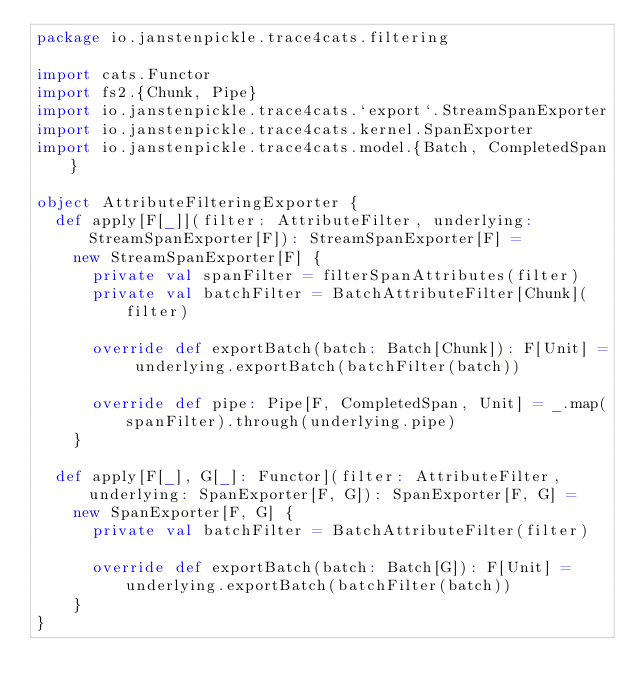Convert code to text. <code><loc_0><loc_0><loc_500><loc_500><_Scala_>package io.janstenpickle.trace4cats.filtering

import cats.Functor
import fs2.{Chunk, Pipe}
import io.janstenpickle.trace4cats.`export`.StreamSpanExporter
import io.janstenpickle.trace4cats.kernel.SpanExporter
import io.janstenpickle.trace4cats.model.{Batch, CompletedSpan}

object AttributeFilteringExporter {
  def apply[F[_]](filter: AttributeFilter, underlying: StreamSpanExporter[F]): StreamSpanExporter[F] =
    new StreamSpanExporter[F] {
      private val spanFilter = filterSpanAttributes(filter)
      private val batchFilter = BatchAttributeFilter[Chunk](filter)

      override def exportBatch(batch: Batch[Chunk]): F[Unit] = underlying.exportBatch(batchFilter(batch))

      override def pipe: Pipe[F, CompletedSpan, Unit] = _.map(spanFilter).through(underlying.pipe)
    }

  def apply[F[_], G[_]: Functor](filter: AttributeFilter, underlying: SpanExporter[F, G]): SpanExporter[F, G] =
    new SpanExporter[F, G] {
      private val batchFilter = BatchAttributeFilter(filter)

      override def exportBatch(batch: Batch[G]): F[Unit] = underlying.exportBatch(batchFilter(batch))
    }
}
</code> 